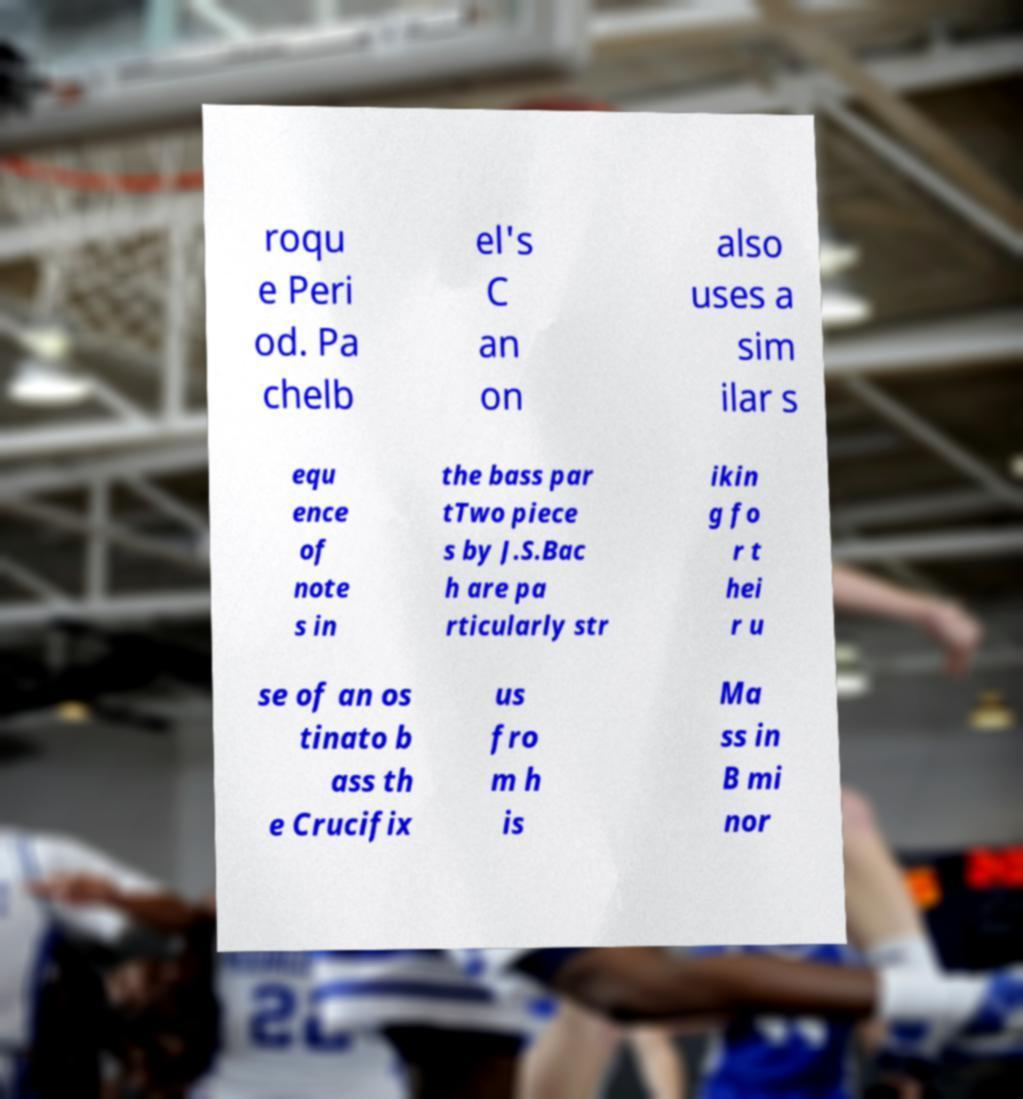There's text embedded in this image that I need extracted. Can you transcribe it verbatim? roqu e Peri od. Pa chelb el's C an on also uses a sim ilar s equ ence of note s in the bass par tTwo piece s by J.S.Bac h are pa rticularly str ikin g fo r t hei r u se of an os tinato b ass th e Crucifix us fro m h is Ma ss in B mi nor 